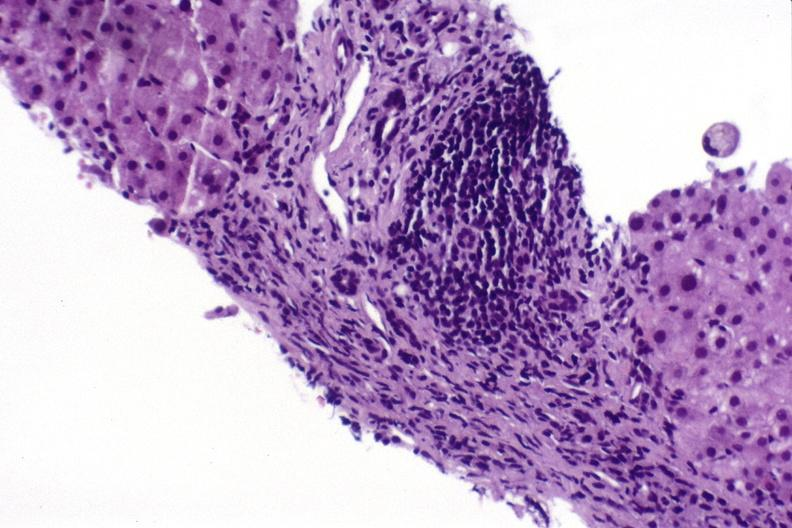s hepatobiliary present?
Answer the question using a single word or phrase. Yes 